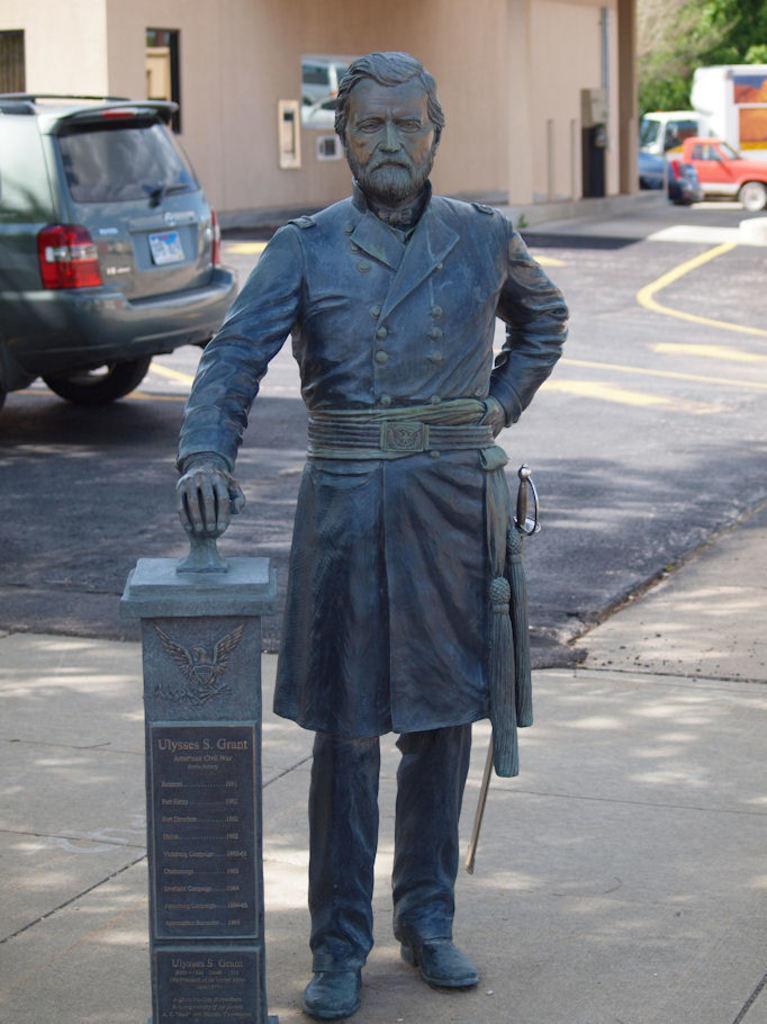Could you give a brief overview of what you see in this image? In this image I can see a statue. I can see the vehicles on the road. In the background, I can see the trees and a building. 